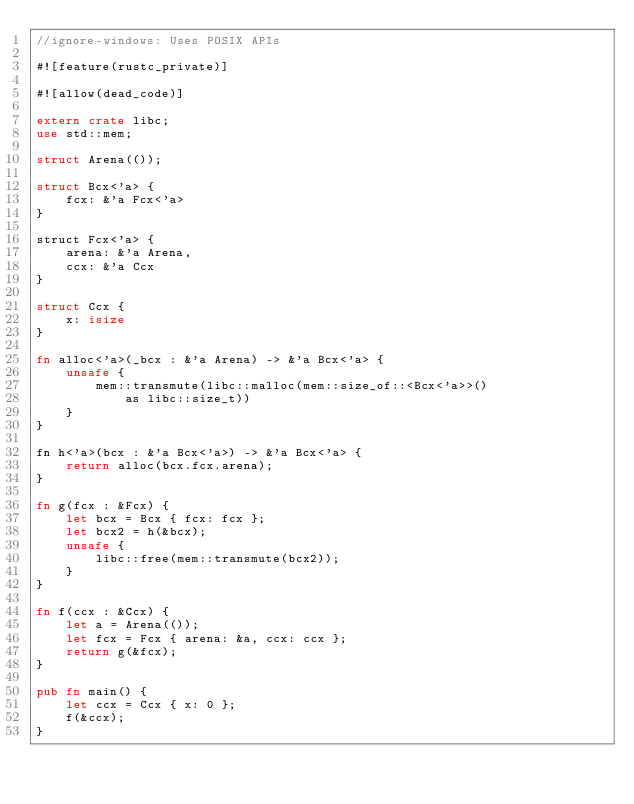Convert code to text. <code><loc_0><loc_0><loc_500><loc_500><_Rust_>//ignore-windows: Uses POSIX APIs

#![feature(rustc_private)]

#![allow(dead_code)]

extern crate libc;
use std::mem;

struct Arena(());

struct Bcx<'a> {
    fcx: &'a Fcx<'a>
}

struct Fcx<'a> {
    arena: &'a Arena,
    ccx: &'a Ccx
}

struct Ccx {
    x: isize
}

fn alloc<'a>(_bcx : &'a Arena) -> &'a Bcx<'a> {
    unsafe {
        mem::transmute(libc::malloc(mem::size_of::<Bcx<'a>>()
            as libc::size_t))
    }
}

fn h<'a>(bcx : &'a Bcx<'a>) -> &'a Bcx<'a> {
    return alloc(bcx.fcx.arena);
}

fn g(fcx : &Fcx) {
    let bcx = Bcx { fcx: fcx };
    let bcx2 = h(&bcx);
    unsafe {
        libc::free(mem::transmute(bcx2));
    }
}

fn f(ccx : &Ccx) {
    let a = Arena(());
    let fcx = Fcx { arena: &a, ccx: ccx };
    return g(&fcx);
}

pub fn main() {
    let ccx = Ccx { x: 0 };
    f(&ccx);
}
</code> 